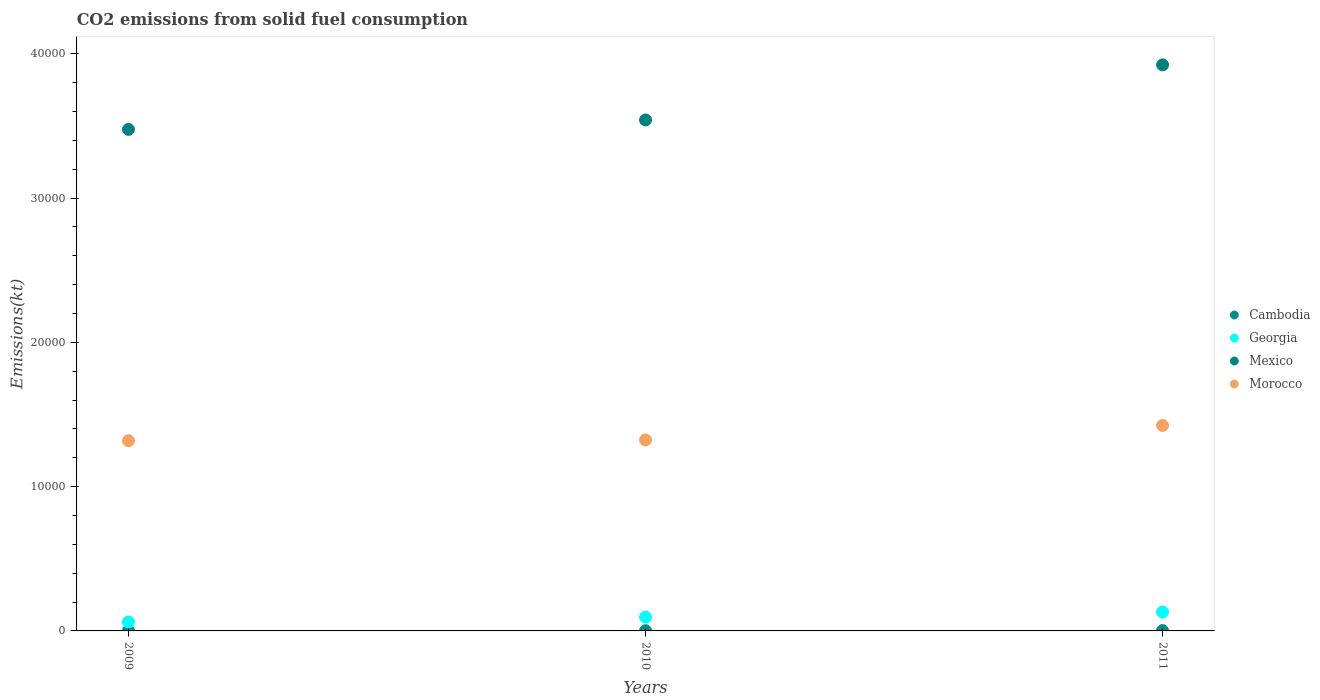Is the number of dotlines equal to the number of legend labels?
Your answer should be compact. Yes. What is the amount of CO2 emitted in Georgia in 2010?
Ensure brevity in your answer.  957.09. Across all years, what is the maximum amount of CO2 emitted in Mexico?
Provide a succinct answer. 3.92e+04. Across all years, what is the minimum amount of CO2 emitted in Georgia?
Provide a short and direct response. 619.72. In which year was the amount of CO2 emitted in Georgia minimum?
Give a very brief answer. 2009. What is the total amount of CO2 emitted in Morocco in the graph?
Provide a succinct answer. 4.07e+04. What is the difference between the amount of CO2 emitted in Georgia in 2009 and that in 2011?
Give a very brief answer. -689.4. What is the difference between the amount of CO2 emitted in Morocco in 2011 and the amount of CO2 emitted in Georgia in 2010?
Offer a very short reply. 1.33e+04. What is the average amount of CO2 emitted in Mexico per year?
Offer a terse response. 3.65e+04. In the year 2010, what is the difference between the amount of CO2 emitted in Georgia and amount of CO2 emitted in Morocco?
Make the answer very short. -1.23e+04. What is the difference between the highest and the second highest amount of CO2 emitted in Morocco?
Your answer should be very brief. 1004.76. What is the difference between the highest and the lowest amount of CO2 emitted in Morocco?
Your response must be concise. 1059.76. Is the sum of the amount of CO2 emitted in Cambodia in 2010 and 2011 greater than the maximum amount of CO2 emitted in Mexico across all years?
Make the answer very short. No. Is it the case that in every year, the sum of the amount of CO2 emitted in Georgia and amount of CO2 emitted in Morocco  is greater than the sum of amount of CO2 emitted in Mexico and amount of CO2 emitted in Cambodia?
Give a very brief answer. No. Is the amount of CO2 emitted in Mexico strictly greater than the amount of CO2 emitted in Morocco over the years?
Offer a terse response. Yes. Is the amount of CO2 emitted in Morocco strictly less than the amount of CO2 emitted in Georgia over the years?
Offer a terse response. No. Are the values on the major ticks of Y-axis written in scientific E-notation?
Make the answer very short. No. How many legend labels are there?
Offer a very short reply. 4. How are the legend labels stacked?
Provide a succinct answer. Vertical. What is the title of the graph?
Provide a short and direct response. CO2 emissions from solid fuel consumption. What is the label or title of the X-axis?
Offer a very short reply. Years. What is the label or title of the Y-axis?
Offer a terse response. Emissions(kt). What is the Emissions(kt) of Cambodia in 2009?
Give a very brief answer. 18.34. What is the Emissions(kt) of Georgia in 2009?
Offer a very short reply. 619.72. What is the Emissions(kt) of Mexico in 2009?
Make the answer very short. 3.48e+04. What is the Emissions(kt) in Morocco in 2009?
Make the answer very short. 1.32e+04. What is the Emissions(kt) in Cambodia in 2010?
Provide a succinct answer. 18.34. What is the Emissions(kt) of Georgia in 2010?
Your response must be concise. 957.09. What is the Emissions(kt) in Mexico in 2010?
Your response must be concise. 3.54e+04. What is the Emissions(kt) in Morocco in 2010?
Give a very brief answer. 1.32e+04. What is the Emissions(kt) in Cambodia in 2011?
Ensure brevity in your answer.  22. What is the Emissions(kt) of Georgia in 2011?
Keep it short and to the point. 1309.12. What is the Emissions(kt) of Mexico in 2011?
Ensure brevity in your answer.  3.92e+04. What is the Emissions(kt) of Morocco in 2011?
Provide a succinct answer. 1.42e+04. Across all years, what is the maximum Emissions(kt) of Cambodia?
Offer a terse response. 22. Across all years, what is the maximum Emissions(kt) of Georgia?
Your answer should be very brief. 1309.12. Across all years, what is the maximum Emissions(kt) of Mexico?
Ensure brevity in your answer.  3.92e+04. Across all years, what is the maximum Emissions(kt) in Morocco?
Provide a short and direct response. 1.42e+04. Across all years, what is the minimum Emissions(kt) in Cambodia?
Make the answer very short. 18.34. Across all years, what is the minimum Emissions(kt) in Georgia?
Provide a short and direct response. 619.72. Across all years, what is the minimum Emissions(kt) in Mexico?
Ensure brevity in your answer.  3.48e+04. Across all years, what is the minimum Emissions(kt) of Morocco?
Provide a succinct answer. 1.32e+04. What is the total Emissions(kt) in Cambodia in the graph?
Provide a short and direct response. 58.67. What is the total Emissions(kt) of Georgia in the graph?
Your response must be concise. 2885.93. What is the total Emissions(kt) of Mexico in the graph?
Give a very brief answer. 1.09e+05. What is the total Emissions(kt) of Morocco in the graph?
Keep it short and to the point. 4.07e+04. What is the difference between the Emissions(kt) in Georgia in 2009 and that in 2010?
Offer a terse response. -337.36. What is the difference between the Emissions(kt) of Mexico in 2009 and that in 2010?
Ensure brevity in your answer.  -652.73. What is the difference between the Emissions(kt) of Morocco in 2009 and that in 2010?
Provide a succinct answer. -55.01. What is the difference between the Emissions(kt) of Cambodia in 2009 and that in 2011?
Your response must be concise. -3.67. What is the difference between the Emissions(kt) in Georgia in 2009 and that in 2011?
Keep it short and to the point. -689.4. What is the difference between the Emissions(kt) of Mexico in 2009 and that in 2011?
Your answer should be compact. -4470.07. What is the difference between the Emissions(kt) of Morocco in 2009 and that in 2011?
Ensure brevity in your answer.  -1059.76. What is the difference between the Emissions(kt) of Cambodia in 2010 and that in 2011?
Provide a succinct answer. -3.67. What is the difference between the Emissions(kt) of Georgia in 2010 and that in 2011?
Provide a short and direct response. -352.03. What is the difference between the Emissions(kt) in Mexico in 2010 and that in 2011?
Make the answer very short. -3817.35. What is the difference between the Emissions(kt) in Morocco in 2010 and that in 2011?
Offer a terse response. -1004.76. What is the difference between the Emissions(kt) in Cambodia in 2009 and the Emissions(kt) in Georgia in 2010?
Make the answer very short. -938.75. What is the difference between the Emissions(kt) in Cambodia in 2009 and the Emissions(kt) in Mexico in 2010?
Your answer should be very brief. -3.54e+04. What is the difference between the Emissions(kt) of Cambodia in 2009 and the Emissions(kt) of Morocco in 2010?
Offer a terse response. -1.32e+04. What is the difference between the Emissions(kt) of Georgia in 2009 and the Emissions(kt) of Mexico in 2010?
Ensure brevity in your answer.  -3.48e+04. What is the difference between the Emissions(kt) in Georgia in 2009 and the Emissions(kt) in Morocco in 2010?
Make the answer very short. -1.26e+04. What is the difference between the Emissions(kt) in Mexico in 2009 and the Emissions(kt) in Morocco in 2010?
Your response must be concise. 2.15e+04. What is the difference between the Emissions(kt) in Cambodia in 2009 and the Emissions(kt) in Georgia in 2011?
Your response must be concise. -1290.78. What is the difference between the Emissions(kt) in Cambodia in 2009 and the Emissions(kt) in Mexico in 2011?
Ensure brevity in your answer.  -3.92e+04. What is the difference between the Emissions(kt) of Cambodia in 2009 and the Emissions(kt) of Morocco in 2011?
Provide a succinct answer. -1.42e+04. What is the difference between the Emissions(kt) in Georgia in 2009 and the Emissions(kt) in Mexico in 2011?
Provide a succinct answer. -3.86e+04. What is the difference between the Emissions(kt) of Georgia in 2009 and the Emissions(kt) of Morocco in 2011?
Your response must be concise. -1.36e+04. What is the difference between the Emissions(kt) of Mexico in 2009 and the Emissions(kt) of Morocco in 2011?
Provide a short and direct response. 2.05e+04. What is the difference between the Emissions(kt) of Cambodia in 2010 and the Emissions(kt) of Georgia in 2011?
Provide a succinct answer. -1290.78. What is the difference between the Emissions(kt) in Cambodia in 2010 and the Emissions(kt) in Mexico in 2011?
Ensure brevity in your answer.  -3.92e+04. What is the difference between the Emissions(kt) of Cambodia in 2010 and the Emissions(kt) of Morocco in 2011?
Provide a succinct answer. -1.42e+04. What is the difference between the Emissions(kt) of Georgia in 2010 and the Emissions(kt) of Mexico in 2011?
Your response must be concise. -3.83e+04. What is the difference between the Emissions(kt) in Georgia in 2010 and the Emissions(kt) in Morocco in 2011?
Ensure brevity in your answer.  -1.33e+04. What is the difference between the Emissions(kt) of Mexico in 2010 and the Emissions(kt) of Morocco in 2011?
Give a very brief answer. 2.12e+04. What is the average Emissions(kt) in Cambodia per year?
Provide a short and direct response. 19.56. What is the average Emissions(kt) in Georgia per year?
Your response must be concise. 961.98. What is the average Emissions(kt) in Mexico per year?
Keep it short and to the point. 3.65e+04. What is the average Emissions(kt) in Morocco per year?
Your response must be concise. 1.36e+04. In the year 2009, what is the difference between the Emissions(kt) of Cambodia and Emissions(kt) of Georgia?
Your answer should be compact. -601.39. In the year 2009, what is the difference between the Emissions(kt) of Cambodia and Emissions(kt) of Mexico?
Give a very brief answer. -3.47e+04. In the year 2009, what is the difference between the Emissions(kt) of Cambodia and Emissions(kt) of Morocco?
Keep it short and to the point. -1.32e+04. In the year 2009, what is the difference between the Emissions(kt) of Georgia and Emissions(kt) of Mexico?
Give a very brief answer. -3.41e+04. In the year 2009, what is the difference between the Emissions(kt) of Georgia and Emissions(kt) of Morocco?
Ensure brevity in your answer.  -1.26e+04. In the year 2009, what is the difference between the Emissions(kt) in Mexico and Emissions(kt) in Morocco?
Your response must be concise. 2.16e+04. In the year 2010, what is the difference between the Emissions(kt) of Cambodia and Emissions(kt) of Georgia?
Provide a succinct answer. -938.75. In the year 2010, what is the difference between the Emissions(kt) in Cambodia and Emissions(kt) in Mexico?
Offer a very short reply. -3.54e+04. In the year 2010, what is the difference between the Emissions(kt) in Cambodia and Emissions(kt) in Morocco?
Keep it short and to the point. -1.32e+04. In the year 2010, what is the difference between the Emissions(kt) of Georgia and Emissions(kt) of Mexico?
Offer a terse response. -3.45e+04. In the year 2010, what is the difference between the Emissions(kt) in Georgia and Emissions(kt) in Morocco?
Your response must be concise. -1.23e+04. In the year 2010, what is the difference between the Emissions(kt) in Mexico and Emissions(kt) in Morocco?
Ensure brevity in your answer.  2.22e+04. In the year 2011, what is the difference between the Emissions(kt) in Cambodia and Emissions(kt) in Georgia?
Keep it short and to the point. -1287.12. In the year 2011, what is the difference between the Emissions(kt) of Cambodia and Emissions(kt) of Mexico?
Your response must be concise. -3.92e+04. In the year 2011, what is the difference between the Emissions(kt) in Cambodia and Emissions(kt) in Morocco?
Provide a succinct answer. -1.42e+04. In the year 2011, what is the difference between the Emissions(kt) in Georgia and Emissions(kt) in Mexico?
Offer a terse response. -3.79e+04. In the year 2011, what is the difference between the Emissions(kt) of Georgia and Emissions(kt) of Morocco?
Give a very brief answer. -1.29e+04. In the year 2011, what is the difference between the Emissions(kt) of Mexico and Emissions(kt) of Morocco?
Offer a very short reply. 2.50e+04. What is the ratio of the Emissions(kt) in Georgia in 2009 to that in 2010?
Keep it short and to the point. 0.65. What is the ratio of the Emissions(kt) of Mexico in 2009 to that in 2010?
Provide a short and direct response. 0.98. What is the ratio of the Emissions(kt) of Cambodia in 2009 to that in 2011?
Your answer should be compact. 0.83. What is the ratio of the Emissions(kt) of Georgia in 2009 to that in 2011?
Your answer should be compact. 0.47. What is the ratio of the Emissions(kt) in Mexico in 2009 to that in 2011?
Give a very brief answer. 0.89. What is the ratio of the Emissions(kt) in Morocco in 2009 to that in 2011?
Your answer should be compact. 0.93. What is the ratio of the Emissions(kt) in Cambodia in 2010 to that in 2011?
Provide a short and direct response. 0.83. What is the ratio of the Emissions(kt) in Georgia in 2010 to that in 2011?
Your answer should be compact. 0.73. What is the ratio of the Emissions(kt) of Mexico in 2010 to that in 2011?
Keep it short and to the point. 0.9. What is the ratio of the Emissions(kt) in Morocco in 2010 to that in 2011?
Your answer should be very brief. 0.93. What is the difference between the highest and the second highest Emissions(kt) in Cambodia?
Your answer should be compact. 3.67. What is the difference between the highest and the second highest Emissions(kt) of Georgia?
Offer a terse response. 352.03. What is the difference between the highest and the second highest Emissions(kt) of Mexico?
Make the answer very short. 3817.35. What is the difference between the highest and the second highest Emissions(kt) of Morocco?
Offer a very short reply. 1004.76. What is the difference between the highest and the lowest Emissions(kt) in Cambodia?
Keep it short and to the point. 3.67. What is the difference between the highest and the lowest Emissions(kt) in Georgia?
Make the answer very short. 689.4. What is the difference between the highest and the lowest Emissions(kt) in Mexico?
Ensure brevity in your answer.  4470.07. What is the difference between the highest and the lowest Emissions(kt) in Morocco?
Your answer should be compact. 1059.76. 